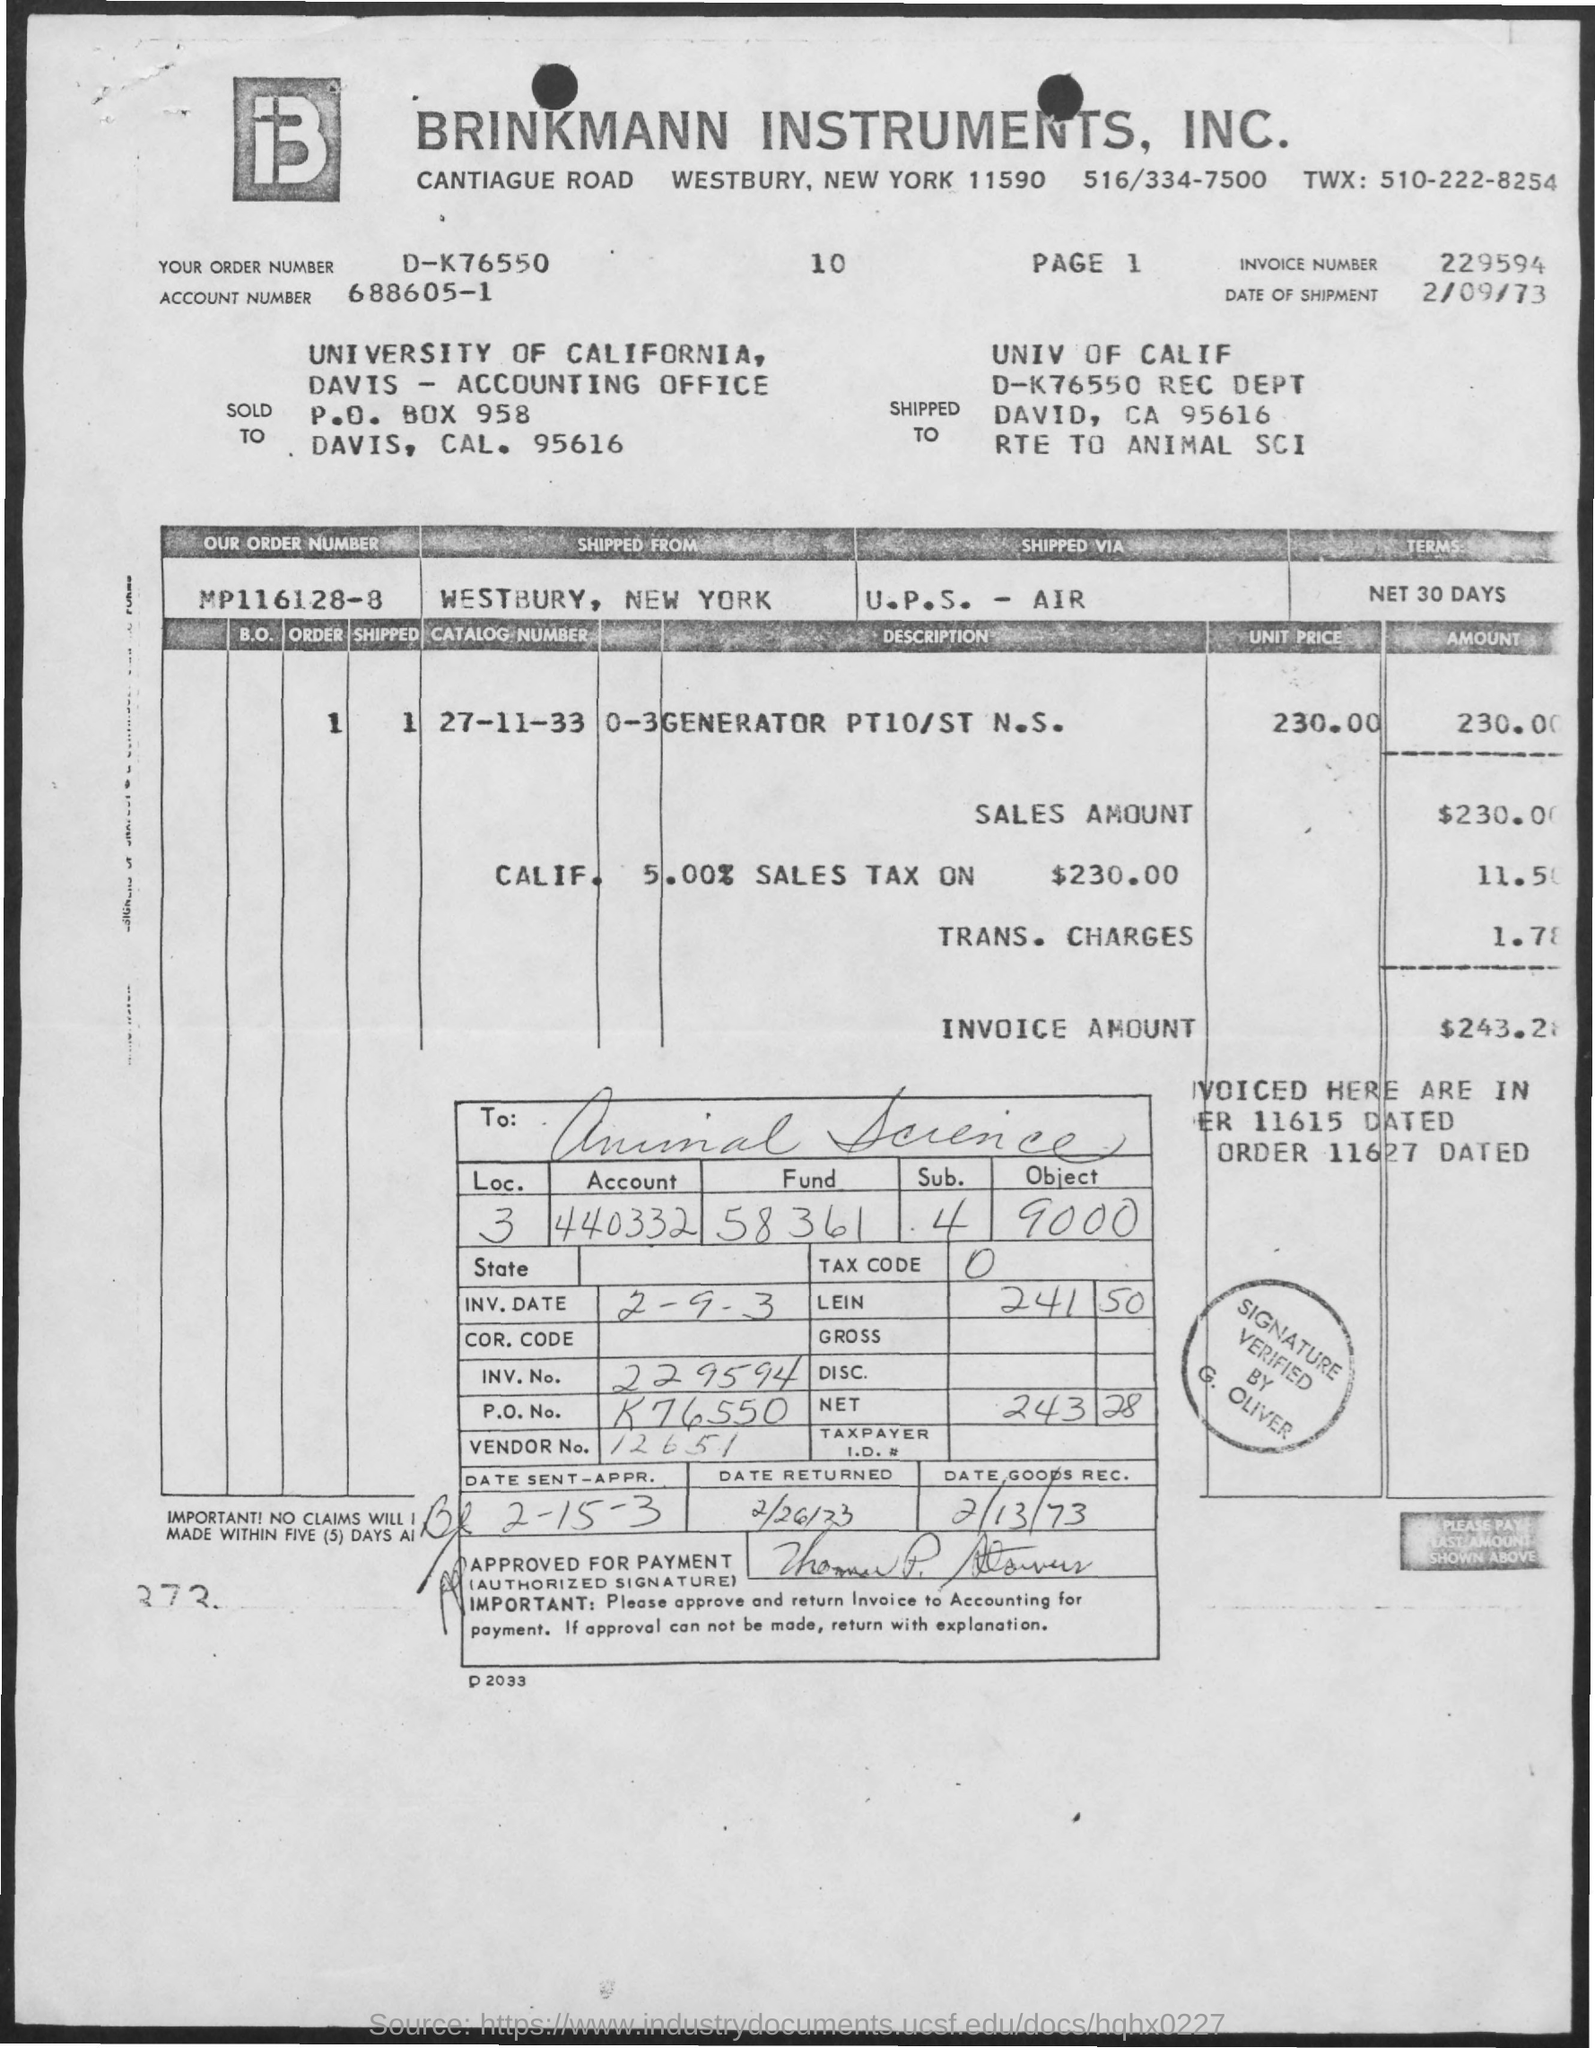Identify some key points in this picture. The name of the university is the University of California. On what date was the goods received? The vendor number is 12651. I would like to know the invoice number for 229594... The date of shipment is February 9, 1973. 